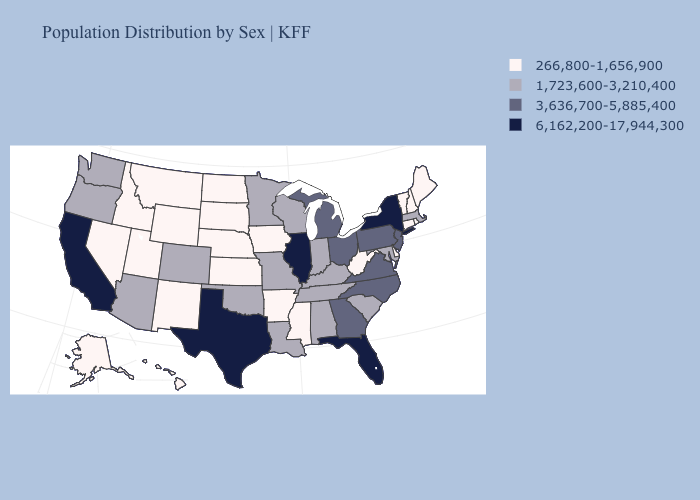Does Michigan have the lowest value in the USA?
Short answer required. No. Does Michigan have the lowest value in the MidWest?
Keep it brief. No. Among the states that border Virginia , which have the highest value?
Short answer required. North Carolina. What is the value of Alaska?
Short answer required. 266,800-1,656,900. What is the value of South Dakota?
Be succinct. 266,800-1,656,900. What is the highest value in the USA?
Answer briefly. 6,162,200-17,944,300. What is the value of Virginia?
Quick response, please. 3,636,700-5,885,400. Does the first symbol in the legend represent the smallest category?
Be succinct. Yes. Name the states that have a value in the range 6,162,200-17,944,300?
Short answer required. California, Florida, Illinois, New York, Texas. Name the states that have a value in the range 1,723,600-3,210,400?
Keep it brief. Alabama, Arizona, Colorado, Indiana, Kentucky, Louisiana, Maryland, Massachusetts, Minnesota, Missouri, Oklahoma, Oregon, South Carolina, Tennessee, Washington, Wisconsin. Name the states that have a value in the range 6,162,200-17,944,300?
Quick response, please. California, Florida, Illinois, New York, Texas. Which states have the lowest value in the USA?
Write a very short answer. Alaska, Arkansas, Connecticut, Delaware, Hawaii, Idaho, Iowa, Kansas, Maine, Mississippi, Montana, Nebraska, Nevada, New Hampshire, New Mexico, North Dakota, Rhode Island, South Dakota, Utah, Vermont, West Virginia, Wyoming. Among the states that border Maine , which have the highest value?
Be succinct. New Hampshire. Name the states that have a value in the range 6,162,200-17,944,300?
Be succinct. California, Florida, Illinois, New York, Texas. Which states have the highest value in the USA?
Write a very short answer. California, Florida, Illinois, New York, Texas. 